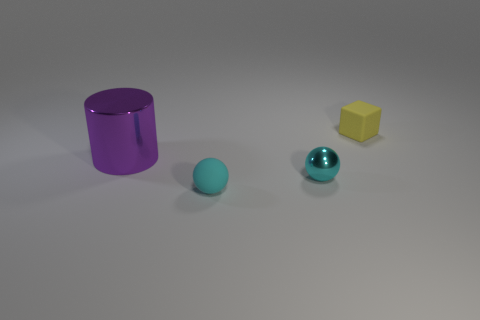The block that is behind the small matte thing to the left of the object behind the big shiny object is made of what material?
Provide a short and direct response. Rubber. What is the tiny object left of the small shiny sphere made of?
Provide a short and direct response. Rubber. Does the thing that is behind the cylinder have the same material as the cylinder?
Offer a very short reply. No. There is a rubber object that is in front of the small cyan shiny object; does it have the same shape as the small shiny thing?
Offer a terse response. Yes. Are there any tiny blue metallic balls?
Your answer should be compact. No. Is there anything else that is the same shape as the large object?
Your response must be concise. No. Is the number of metallic objects behind the tiny metallic ball greater than the number of big red objects?
Make the answer very short. Yes. There is a purple metallic thing; are there any blocks left of it?
Your response must be concise. No. Do the cyan matte thing and the yellow matte object have the same size?
Your answer should be very brief. Yes. There is a cyan rubber thing that is the same shape as the small metallic thing; what size is it?
Ensure brevity in your answer.  Small. 